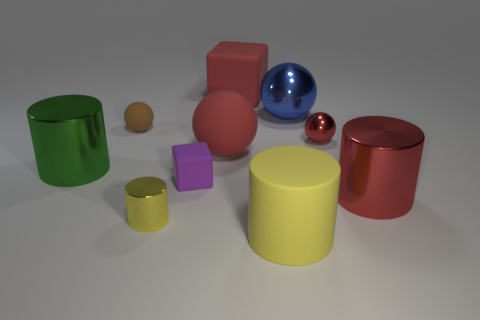Can you tell which objects are reflective and which ones are not? Certainly! In the image, the reflective qualities are distinctive. Both spheres, the blue and the red, exhibit shiny surfaces that mirror their surroundings, indicating that they are reflective. The other objects possess a matte finish, diffusing light rather than reflecting it, which suggests they are non-reflective. 